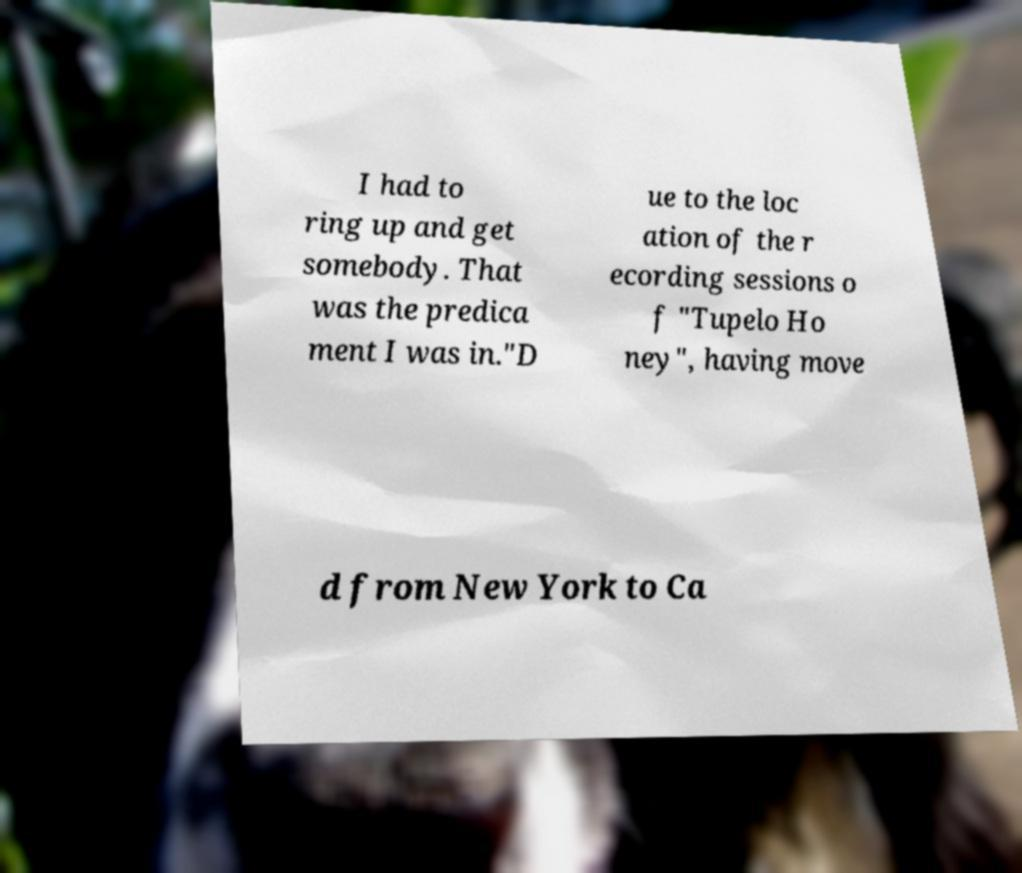Can you accurately transcribe the text from the provided image for me? I had to ring up and get somebody. That was the predica ment I was in."D ue to the loc ation of the r ecording sessions o f "Tupelo Ho ney", having move d from New York to Ca 